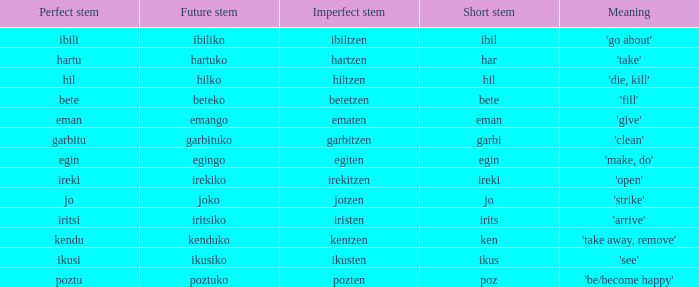What is the number for future stem for poztu? 1.0. 